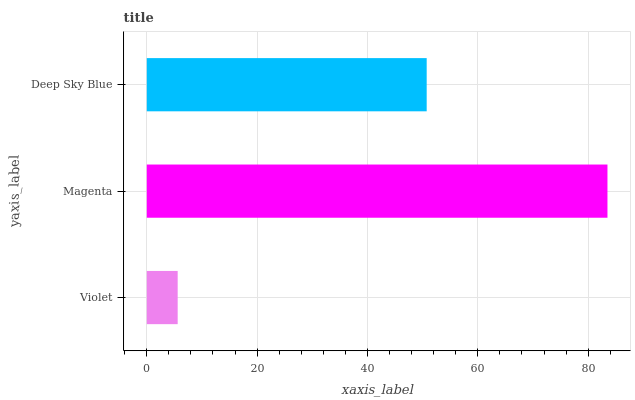Is Violet the minimum?
Answer yes or no. Yes. Is Magenta the maximum?
Answer yes or no. Yes. Is Deep Sky Blue the minimum?
Answer yes or no. No. Is Deep Sky Blue the maximum?
Answer yes or no. No. Is Magenta greater than Deep Sky Blue?
Answer yes or no. Yes. Is Deep Sky Blue less than Magenta?
Answer yes or no. Yes. Is Deep Sky Blue greater than Magenta?
Answer yes or no. No. Is Magenta less than Deep Sky Blue?
Answer yes or no. No. Is Deep Sky Blue the high median?
Answer yes or no. Yes. Is Deep Sky Blue the low median?
Answer yes or no. Yes. Is Violet the high median?
Answer yes or no. No. Is Violet the low median?
Answer yes or no. No. 